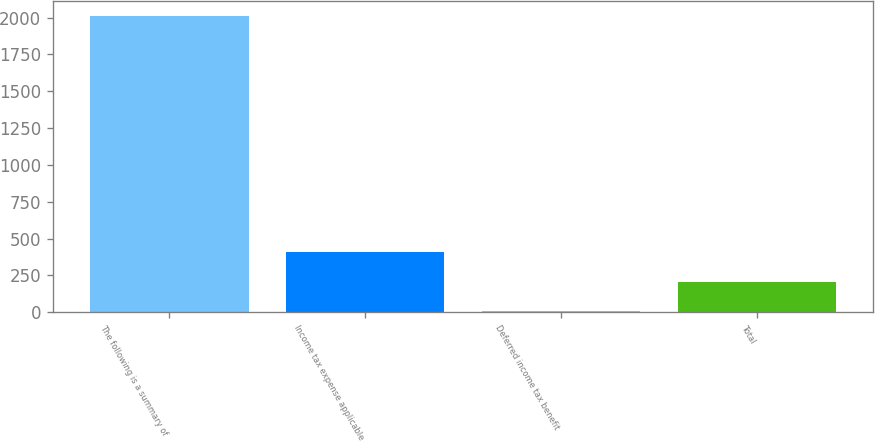Convert chart. <chart><loc_0><loc_0><loc_500><loc_500><bar_chart><fcel>The following is a summary of<fcel>Income tax expense applicable<fcel>Deferred income tax benefit<fcel>Total<nl><fcel>2014<fcel>408.16<fcel>6.7<fcel>207.43<nl></chart> 